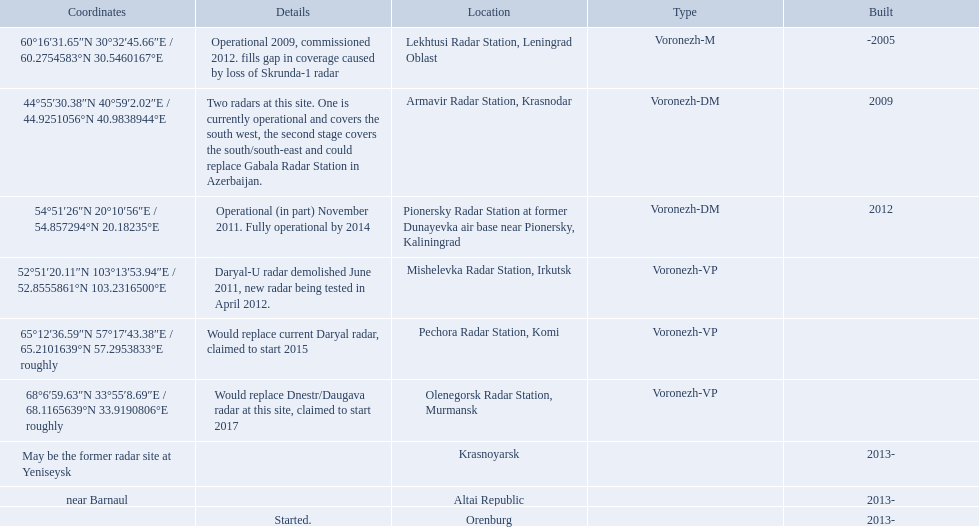Voronezh radar has locations where? Lekhtusi Radar Station, Leningrad Oblast, Armavir Radar Station, Krasnodar, Pionersky Radar Station at former Dunayevka air base near Pionersky, Kaliningrad, Mishelevka Radar Station, Irkutsk, Pechora Radar Station, Komi, Olenegorsk Radar Station, Murmansk, Krasnoyarsk, Altai Republic, Orenburg. Which of these locations have know coordinates? Lekhtusi Radar Station, Leningrad Oblast, Armavir Radar Station, Krasnodar, Pionersky Radar Station at former Dunayevka air base near Pionersky, Kaliningrad, Mishelevka Radar Station, Irkutsk, Pechora Radar Station, Komi, Olenegorsk Radar Station, Murmansk. Which of these locations has coordinates of 60deg16'31.65''n 30deg32'45.66''e / 60.2754583degn 30.5460167dege? Lekhtusi Radar Station, Leningrad Oblast. 